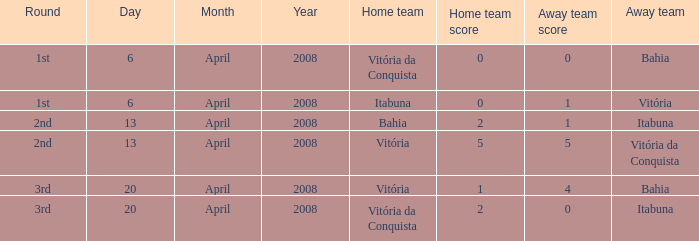What domestic team has a score of 5 - 5? Vitória. Can you give me this table as a dict? {'header': ['Round', 'Day', 'Month', 'Year', 'Home team', 'Home team score', 'Away team score', 'Away team'], 'rows': [['1st', '6', 'April', '2008', 'Vitória da Conquista', '0', '0', 'Bahia'], ['1st', '6', 'April', '2008', 'Itabuna', '0', '1', 'Vitória'], ['2nd', '13', 'April', '2008', 'Bahia', '2', '1', 'Itabuna'], ['2nd', '13', 'April', '2008', 'Vitória', '5', '5', 'Vitória da Conquista'], ['3rd', '20', 'April', '2008', 'Vitória', '1', '4', 'Bahia'], ['3rd', '20', 'April', '2008', 'Vitória da Conquista', '2', '0', 'Itabuna']]} 